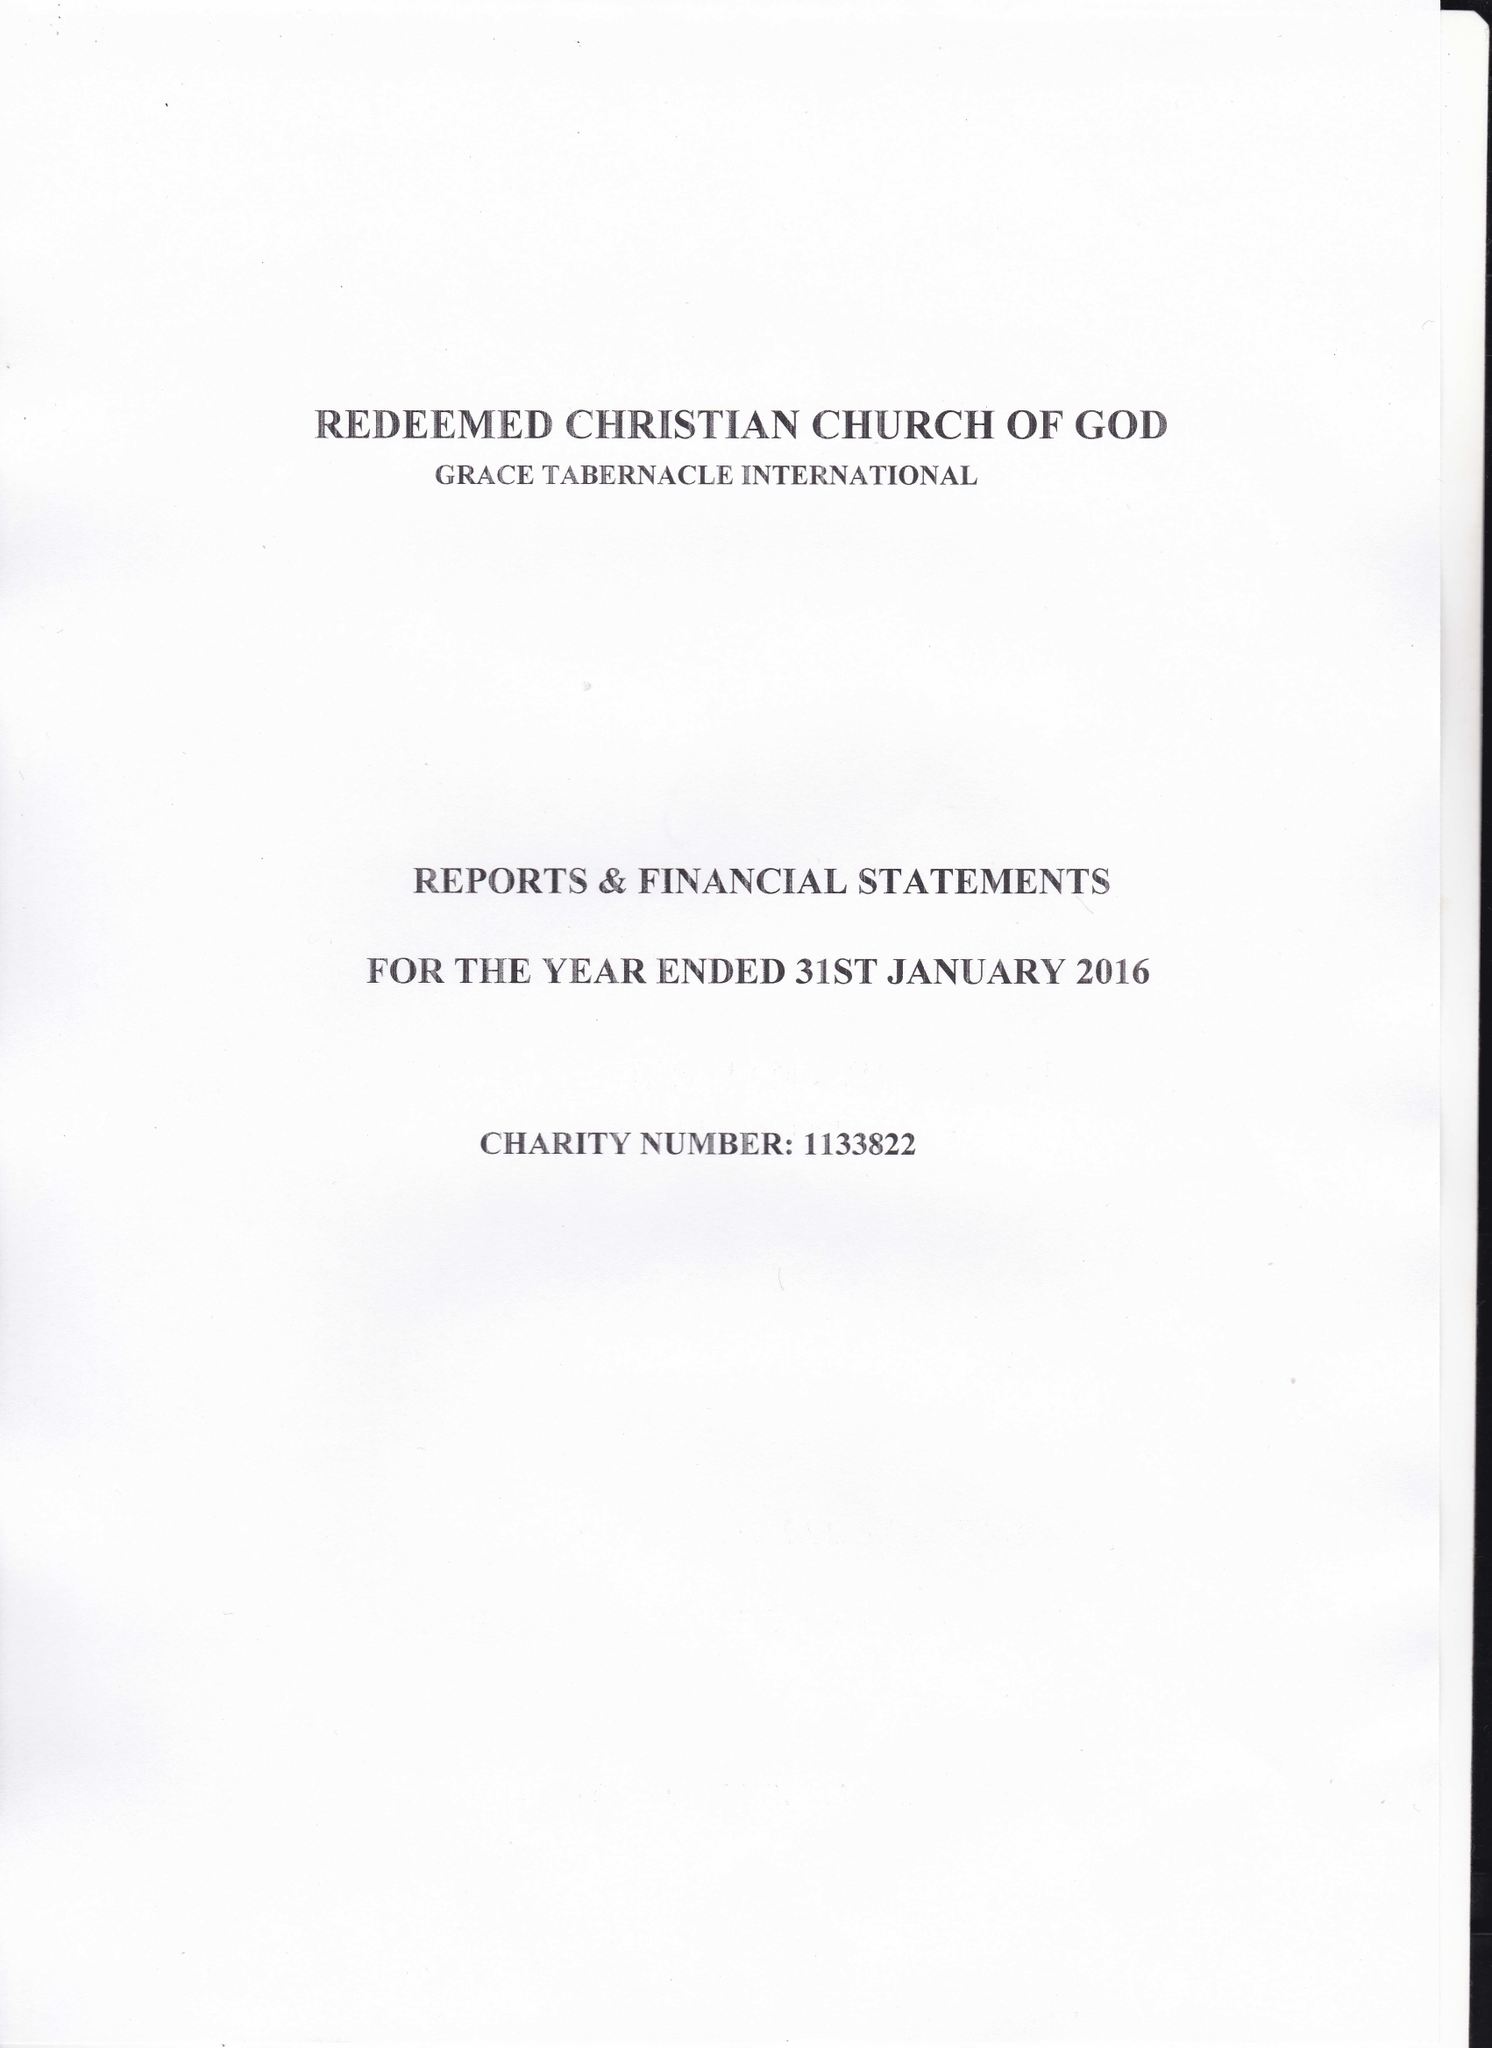What is the value for the spending_annually_in_british_pounds?
Answer the question using a single word or phrase. 32372.00 